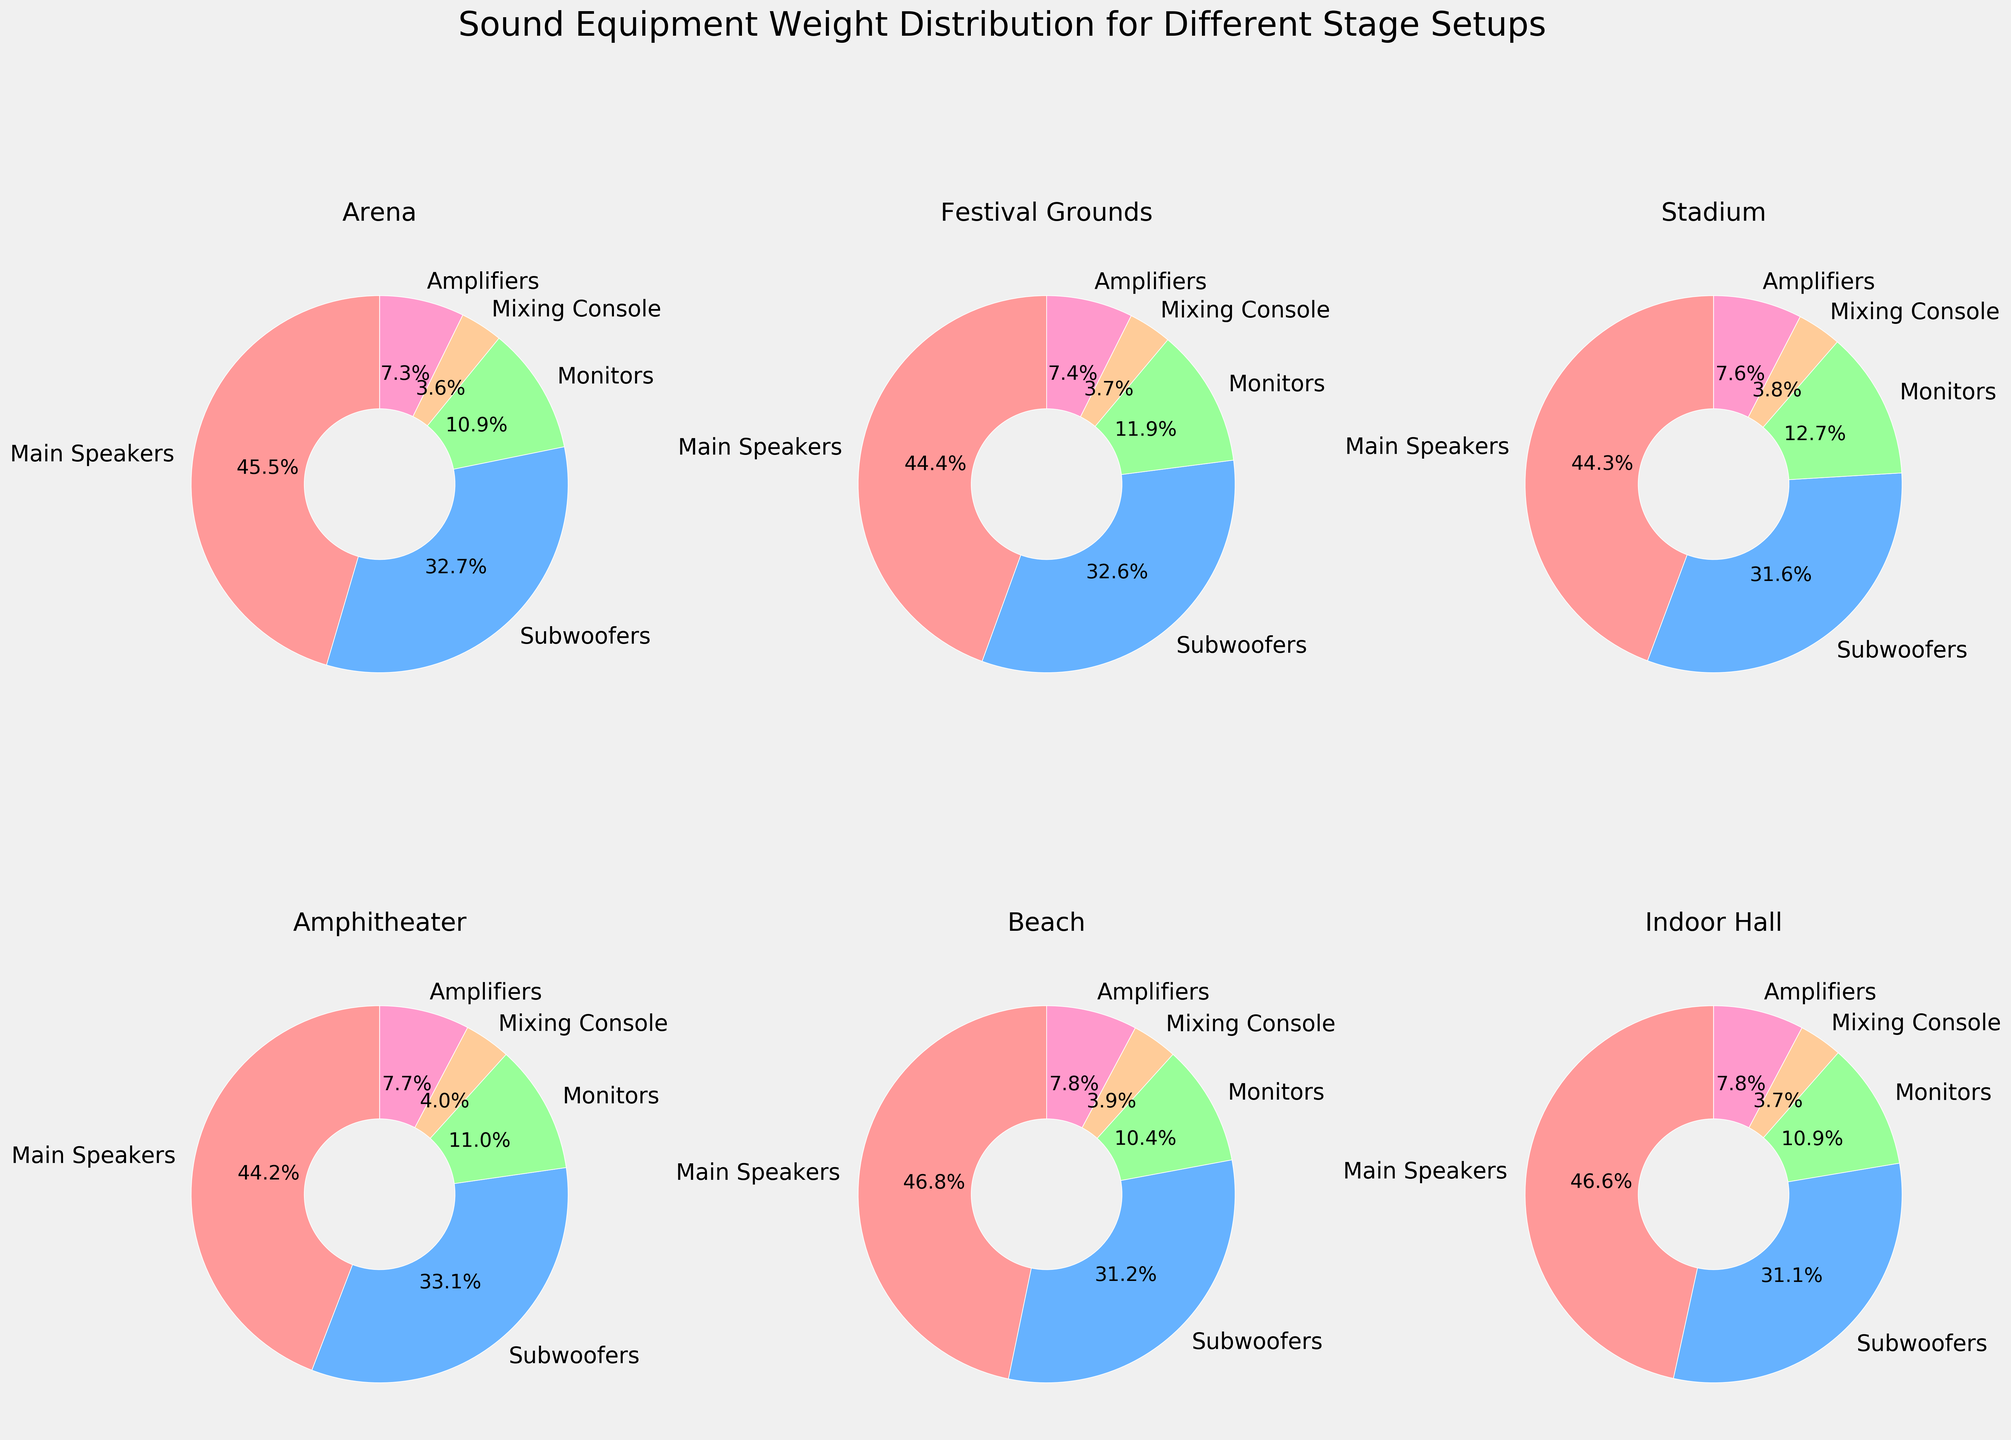What is the overall title of the figure? The title is positioned at the top of the figure, indicating the main subject, which is the weight distribution of sound equipment for various stage setups.
Answer: Sound Equipment Weight Distribution for Different Stage Setups What percentage of the total weight do the Main Speakers account for in the Arena setup? In the Arena setup pie chart, the wedge labeled "Main Speakers" indicates that the Main Speakers account for 46.3% of the total weight.
Answer: 46.3% Which stage setup has the highest weight for Subwoofers? By observing each pie chart, the Stadium setup has the highest proportion for Subwoofers, amounting to 2500 units.
Answer: Stadium Comparing the weight distribution of Monitors, which setup has the smallest portion? By comparing all pie charts for the Monitors category, the Indoor Hall setup has the smallest portion for Monitors, with 350 units representing a minimal percentage.
Answer: Indoor Hall What is the difference in the weight percentage of Amplifiers between the Beach and the Stadium setups? In the Beach setup, Amplifiers account for 6.7%, while in the Stadium setup, they account for 7.4%. The difference is calculated as 7.4% - 6.7% = 0.7%.
Answer: 0.7% How does the total weight of sound equipment for the Amphitheater compare to that of the Festival Grounds? Summing up all weight components for each setup, the Amphitheater totals 4530 units, while the Festival Grounds total 6750 units. The difference is 6750 - 4530 = 2220 units.
Answer: 2220 units Which equipment type has the most balanced weight distribution across all setups? Analyzing the pie charts for each setup, the Mixing Console appears to have the most balanced distribution across all stage setups since its wedge sizes are relatively similar across all setups.
Answer: Mixing Console What is the combined weight percentage of Main Speakers and Subwoofers in the Stadium setup? In the Stadium setup pie chart, the Main Speakers and Subwoofers account for 48% and 34.3%, respectively. The combined percentage is 48% + 34.3% = 82.3%.
Answer: 82.3% In which setup do the Amplifiers make up the largest percentage of the total weight? Based on observations of each pie chart, the Stadium setup has Amplifiers making up the largest portion, equating to a higher percentage compared to other setups.
Answer: Stadium 